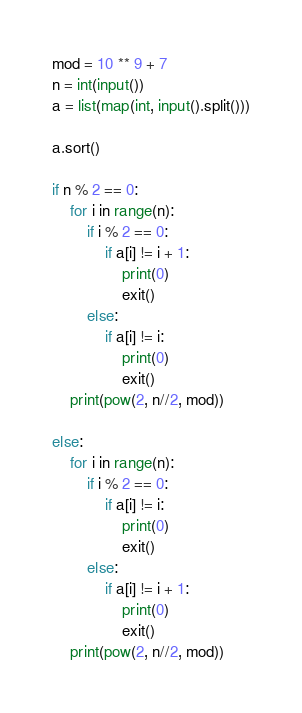<code> <loc_0><loc_0><loc_500><loc_500><_Python_>mod = 10 ** 9 + 7
n = int(input())
a = list(map(int, input().split()))

a.sort()

if n % 2 == 0:
    for i in range(n):
        if i % 2 == 0:
            if a[i] != i + 1:
                print(0)
                exit()
        else:
            if a[i] != i:
                print(0)
                exit()
    print(pow(2, n//2, mod))

else:
    for i in range(n):
        if i % 2 == 0:
            if a[i] != i:
                print(0)
                exit()
        else:
            if a[i] != i + 1:
                print(0)
                exit()
    print(pow(2, n//2, mod))</code> 